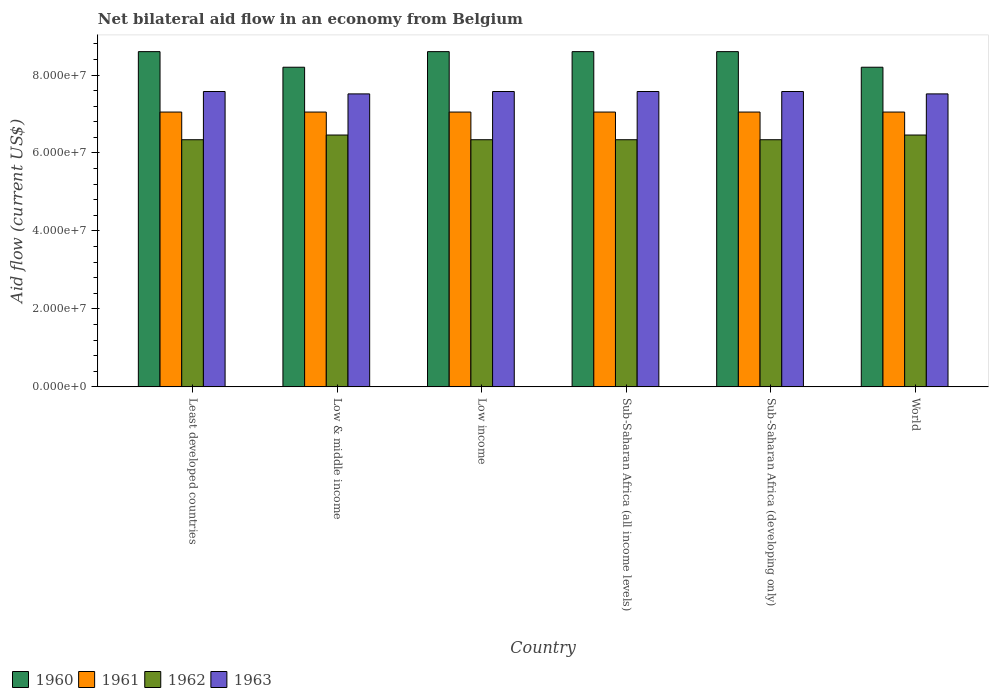How many groups of bars are there?
Your answer should be very brief. 6. Are the number of bars per tick equal to the number of legend labels?
Offer a very short reply. Yes. Are the number of bars on each tick of the X-axis equal?
Give a very brief answer. Yes. How many bars are there on the 6th tick from the left?
Keep it short and to the point. 4. In how many cases, is the number of bars for a given country not equal to the number of legend labels?
Ensure brevity in your answer.  0. What is the net bilateral aid flow in 1960 in Low income?
Your answer should be very brief. 8.60e+07. Across all countries, what is the maximum net bilateral aid flow in 1963?
Offer a terse response. 7.58e+07. Across all countries, what is the minimum net bilateral aid flow in 1962?
Provide a short and direct response. 6.34e+07. In which country was the net bilateral aid flow in 1963 maximum?
Your answer should be compact. Least developed countries. In which country was the net bilateral aid flow in 1962 minimum?
Your answer should be very brief. Least developed countries. What is the total net bilateral aid flow in 1962 in the graph?
Provide a short and direct response. 3.83e+08. What is the difference between the net bilateral aid flow in 1961 in Least developed countries and the net bilateral aid flow in 1960 in World?
Your answer should be compact. -1.15e+07. What is the average net bilateral aid flow in 1960 per country?
Give a very brief answer. 8.47e+07. What is the difference between the net bilateral aid flow of/in 1963 and net bilateral aid flow of/in 1960 in Low & middle income?
Provide a succinct answer. -6.84e+06. In how many countries, is the net bilateral aid flow in 1963 greater than 28000000 US$?
Your response must be concise. 6. What is the ratio of the net bilateral aid flow in 1962 in Low & middle income to that in Sub-Saharan Africa (all income levels)?
Provide a succinct answer. 1.02. Is the net bilateral aid flow in 1963 in Least developed countries less than that in World?
Make the answer very short. No. What is the difference between the highest and the second highest net bilateral aid flow in 1962?
Offer a very short reply. 1.21e+06. Is the sum of the net bilateral aid flow in 1962 in Sub-Saharan Africa (developing only) and World greater than the maximum net bilateral aid flow in 1963 across all countries?
Your response must be concise. Yes. Is it the case that in every country, the sum of the net bilateral aid flow in 1961 and net bilateral aid flow in 1960 is greater than the sum of net bilateral aid flow in 1963 and net bilateral aid flow in 1962?
Keep it short and to the point. No. What does the 1st bar from the left in Least developed countries represents?
Offer a very short reply. 1960. How many bars are there?
Your answer should be compact. 24. How many countries are there in the graph?
Keep it short and to the point. 6. What is the difference between two consecutive major ticks on the Y-axis?
Provide a short and direct response. 2.00e+07. Does the graph contain any zero values?
Give a very brief answer. No. Does the graph contain grids?
Provide a succinct answer. No. Where does the legend appear in the graph?
Provide a succinct answer. Bottom left. How many legend labels are there?
Your response must be concise. 4. How are the legend labels stacked?
Keep it short and to the point. Horizontal. What is the title of the graph?
Give a very brief answer. Net bilateral aid flow in an economy from Belgium. Does "2002" appear as one of the legend labels in the graph?
Ensure brevity in your answer.  No. What is the label or title of the Y-axis?
Offer a very short reply. Aid flow (current US$). What is the Aid flow (current US$) in 1960 in Least developed countries?
Your response must be concise. 8.60e+07. What is the Aid flow (current US$) in 1961 in Least developed countries?
Offer a terse response. 7.05e+07. What is the Aid flow (current US$) of 1962 in Least developed countries?
Your answer should be very brief. 6.34e+07. What is the Aid flow (current US$) in 1963 in Least developed countries?
Your answer should be very brief. 7.58e+07. What is the Aid flow (current US$) of 1960 in Low & middle income?
Provide a succinct answer. 8.20e+07. What is the Aid flow (current US$) of 1961 in Low & middle income?
Keep it short and to the point. 7.05e+07. What is the Aid flow (current US$) of 1962 in Low & middle income?
Your answer should be compact. 6.46e+07. What is the Aid flow (current US$) of 1963 in Low & middle income?
Provide a succinct answer. 7.52e+07. What is the Aid flow (current US$) of 1960 in Low income?
Provide a succinct answer. 8.60e+07. What is the Aid flow (current US$) in 1961 in Low income?
Your response must be concise. 7.05e+07. What is the Aid flow (current US$) of 1962 in Low income?
Give a very brief answer. 6.34e+07. What is the Aid flow (current US$) of 1963 in Low income?
Give a very brief answer. 7.58e+07. What is the Aid flow (current US$) of 1960 in Sub-Saharan Africa (all income levels)?
Offer a terse response. 8.60e+07. What is the Aid flow (current US$) in 1961 in Sub-Saharan Africa (all income levels)?
Keep it short and to the point. 7.05e+07. What is the Aid flow (current US$) of 1962 in Sub-Saharan Africa (all income levels)?
Give a very brief answer. 6.34e+07. What is the Aid flow (current US$) in 1963 in Sub-Saharan Africa (all income levels)?
Give a very brief answer. 7.58e+07. What is the Aid flow (current US$) of 1960 in Sub-Saharan Africa (developing only)?
Give a very brief answer. 8.60e+07. What is the Aid flow (current US$) of 1961 in Sub-Saharan Africa (developing only)?
Provide a succinct answer. 7.05e+07. What is the Aid flow (current US$) of 1962 in Sub-Saharan Africa (developing only)?
Provide a short and direct response. 6.34e+07. What is the Aid flow (current US$) of 1963 in Sub-Saharan Africa (developing only)?
Your response must be concise. 7.58e+07. What is the Aid flow (current US$) in 1960 in World?
Your answer should be compact. 8.20e+07. What is the Aid flow (current US$) of 1961 in World?
Your response must be concise. 7.05e+07. What is the Aid flow (current US$) in 1962 in World?
Make the answer very short. 6.46e+07. What is the Aid flow (current US$) in 1963 in World?
Your response must be concise. 7.52e+07. Across all countries, what is the maximum Aid flow (current US$) of 1960?
Your response must be concise. 8.60e+07. Across all countries, what is the maximum Aid flow (current US$) in 1961?
Make the answer very short. 7.05e+07. Across all countries, what is the maximum Aid flow (current US$) in 1962?
Offer a very short reply. 6.46e+07. Across all countries, what is the maximum Aid flow (current US$) of 1963?
Provide a succinct answer. 7.58e+07. Across all countries, what is the minimum Aid flow (current US$) of 1960?
Offer a terse response. 8.20e+07. Across all countries, what is the minimum Aid flow (current US$) in 1961?
Give a very brief answer. 7.05e+07. Across all countries, what is the minimum Aid flow (current US$) of 1962?
Offer a terse response. 6.34e+07. Across all countries, what is the minimum Aid flow (current US$) in 1963?
Offer a very short reply. 7.52e+07. What is the total Aid flow (current US$) of 1960 in the graph?
Offer a very short reply. 5.08e+08. What is the total Aid flow (current US$) of 1961 in the graph?
Make the answer very short. 4.23e+08. What is the total Aid flow (current US$) of 1962 in the graph?
Your answer should be very brief. 3.83e+08. What is the total Aid flow (current US$) in 1963 in the graph?
Ensure brevity in your answer.  4.53e+08. What is the difference between the Aid flow (current US$) of 1962 in Least developed countries and that in Low & middle income?
Ensure brevity in your answer.  -1.21e+06. What is the difference between the Aid flow (current US$) in 1961 in Least developed countries and that in Low income?
Provide a succinct answer. 0. What is the difference between the Aid flow (current US$) of 1963 in Least developed countries and that in Low income?
Your answer should be very brief. 0. What is the difference between the Aid flow (current US$) in 1962 in Least developed countries and that in Sub-Saharan Africa (all income levels)?
Ensure brevity in your answer.  0. What is the difference between the Aid flow (current US$) of 1960 in Least developed countries and that in Sub-Saharan Africa (developing only)?
Provide a short and direct response. 0. What is the difference between the Aid flow (current US$) in 1962 in Least developed countries and that in World?
Offer a terse response. -1.21e+06. What is the difference between the Aid flow (current US$) in 1960 in Low & middle income and that in Low income?
Your response must be concise. -4.00e+06. What is the difference between the Aid flow (current US$) in 1961 in Low & middle income and that in Low income?
Offer a very short reply. 0. What is the difference between the Aid flow (current US$) of 1962 in Low & middle income and that in Low income?
Your answer should be compact. 1.21e+06. What is the difference between the Aid flow (current US$) of 1963 in Low & middle income and that in Low income?
Ensure brevity in your answer.  -6.10e+05. What is the difference between the Aid flow (current US$) in 1960 in Low & middle income and that in Sub-Saharan Africa (all income levels)?
Give a very brief answer. -4.00e+06. What is the difference between the Aid flow (current US$) in 1961 in Low & middle income and that in Sub-Saharan Africa (all income levels)?
Ensure brevity in your answer.  0. What is the difference between the Aid flow (current US$) in 1962 in Low & middle income and that in Sub-Saharan Africa (all income levels)?
Offer a terse response. 1.21e+06. What is the difference between the Aid flow (current US$) of 1963 in Low & middle income and that in Sub-Saharan Africa (all income levels)?
Offer a terse response. -6.10e+05. What is the difference between the Aid flow (current US$) in 1962 in Low & middle income and that in Sub-Saharan Africa (developing only)?
Keep it short and to the point. 1.21e+06. What is the difference between the Aid flow (current US$) of 1963 in Low & middle income and that in Sub-Saharan Africa (developing only)?
Ensure brevity in your answer.  -6.10e+05. What is the difference between the Aid flow (current US$) in 1962 in Low & middle income and that in World?
Offer a very short reply. 0. What is the difference between the Aid flow (current US$) of 1963 in Low & middle income and that in World?
Your answer should be very brief. 0. What is the difference between the Aid flow (current US$) of 1960 in Low income and that in Sub-Saharan Africa (all income levels)?
Your answer should be very brief. 0. What is the difference between the Aid flow (current US$) of 1961 in Low income and that in Sub-Saharan Africa (all income levels)?
Keep it short and to the point. 0. What is the difference between the Aid flow (current US$) of 1963 in Low income and that in Sub-Saharan Africa (all income levels)?
Keep it short and to the point. 0. What is the difference between the Aid flow (current US$) in 1960 in Low income and that in Sub-Saharan Africa (developing only)?
Offer a very short reply. 0. What is the difference between the Aid flow (current US$) in 1961 in Low income and that in World?
Your response must be concise. 0. What is the difference between the Aid flow (current US$) of 1962 in Low income and that in World?
Provide a short and direct response. -1.21e+06. What is the difference between the Aid flow (current US$) of 1963 in Low income and that in World?
Keep it short and to the point. 6.10e+05. What is the difference between the Aid flow (current US$) in 1962 in Sub-Saharan Africa (all income levels) and that in Sub-Saharan Africa (developing only)?
Ensure brevity in your answer.  0. What is the difference between the Aid flow (current US$) of 1963 in Sub-Saharan Africa (all income levels) and that in Sub-Saharan Africa (developing only)?
Give a very brief answer. 0. What is the difference between the Aid flow (current US$) in 1962 in Sub-Saharan Africa (all income levels) and that in World?
Provide a succinct answer. -1.21e+06. What is the difference between the Aid flow (current US$) of 1963 in Sub-Saharan Africa (all income levels) and that in World?
Keep it short and to the point. 6.10e+05. What is the difference between the Aid flow (current US$) of 1961 in Sub-Saharan Africa (developing only) and that in World?
Provide a short and direct response. 0. What is the difference between the Aid flow (current US$) of 1962 in Sub-Saharan Africa (developing only) and that in World?
Offer a very short reply. -1.21e+06. What is the difference between the Aid flow (current US$) in 1963 in Sub-Saharan Africa (developing only) and that in World?
Provide a succinct answer. 6.10e+05. What is the difference between the Aid flow (current US$) in 1960 in Least developed countries and the Aid flow (current US$) in 1961 in Low & middle income?
Keep it short and to the point. 1.55e+07. What is the difference between the Aid flow (current US$) in 1960 in Least developed countries and the Aid flow (current US$) in 1962 in Low & middle income?
Your response must be concise. 2.14e+07. What is the difference between the Aid flow (current US$) of 1960 in Least developed countries and the Aid flow (current US$) of 1963 in Low & middle income?
Your answer should be very brief. 1.08e+07. What is the difference between the Aid flow (current US$) in 1961 in Least developed countries and the Aid flow (current US$) in 1962 in Low & middle income?
Your response must be concise. 5.89e+06. What is the difference between the Aid flow (current US$) of 1961 in Least developed countries and the Aid flow (current US$) of 1963 in Low & middle income?
Your answer should be very brief. -4.66e+06. What is the difference between the Aid flow (current US$) of 1962 in Least developed countries and the Aid flow (current US$) of 1963 in Low & middle income?
Make the answer very short. -1.18e+07. What is the difference between the Aid flow (current US$) of 1960 in Least developed countries and the Aid flow (current US$) of 1961 in Low income?
Your response must be concise. 1.55e+07. What is the difference between the Aid flow (current US$) in 1960 in Least developed countries and the Aid flow (current US$) in 1962 in Low income?
Your answer should be very brief. 2.26e+07. What is the difference between the Aid flow (current US$) in 1960 in Least developed countries and the Aid flow (current US$) in 1963 in Low income?
Offer a terse response. 1.02e+07. What is the difference between the Aid flow (current US$) in 1961 in Least developed countries and the Aid flow (current US$) in 1962 in Low income?
Your response must be concise. 7.10e+06. What is the difference between the Aid flow (current US$) in 1961 in Least developed countries and the Aid flow (current US$) in 1963 in Low income?
Ensure brevity in your answer.  -5.27e+06. What is the difference between the Aid flow (current US$) in 1962 in Least developed countries and the Aid flow (current US$) in 1963 in Low income?
Your answer should be compact. -1.24e+07. What is the difference between the Aid flow (current US$) of 1960 in Least developed countries and the Aid flow (current US$) of 1961 in Sub-Saharan Africa (all income levels)?
Provide a succinct answer. 1.55e+07. What is the difference between the Aid flow (current US$) in 1960 in Least developed countries and the Aid flow (current US$) in 1962 in Sub-Saharan Africa (all income levels)?
Provide a short and direct response. 2.26e+07. What is the difference between the Aid flow (current US$) of 1960 in Least developed countries and the Aid flow (current US$) of 1963 in Sub-Saharan Africa (all income levels)?
Your response must be concise. 1.02e+07. What is the difference between the Aid flow (current US$) of 1961 in Least developed countries and the Aid flow (current US$) of 1962 in Sub-Saharan Africa (all income levels)?
Keep it short and to the point. 7.10e+06. What is the difference between the Aid flow (current US$) in 1961 in Least developed countries and the Aid flow (current US$) in 1963 in Sub-Saharan Africa (all income levels)?
Provide a short and direct response. -5.27e+06. What is the difference between the Aid flow (current US$) in 1962 in Least developed countries and the Aid flow (current US$) in 1963 in Sub-Saharan Africa (all income levels)?
Your answer should be very brief. -1.24e+07. What is the difference between the Aid flow (current US$) of 1960 in Least developed countries and the Aid flow (current US$) of 1961 in Sub-Saharan Africa (developing only)?
Ensure brevity in your answer.  1.55e+07. What is the difference between the Aid flow (current US$) in 1960 in Least developed countries and the Aid flow (current US$) in 1962 in Sub-Saharan Africa (developing only)?
Give a very brief answer. 2.26e+07. What is the difference between the Aid flow (current US$) in 1960 in Least developed countries and the Aid flow (current US$) in 1963 in Sub-Saharan Africa (developing only)?
Give a very brief answer. 1.02e+07. What is the difference between the Aid flow (current US$) in 1961 in Least developed countries and the Aid flow (current US$) in 1962 in Sub-Saharan Africa (developing only)?
Your answer should be compact. 7.10e+06. What is the difference between the Aid flow (current US$) in 1961 in Least developed countries and the Aid flow (current US$) in 1963 in Sub-Saharan Africa (developing only)?
Offer a terse response. -5.27e+06. What is the difference between the Aid flow (current US$) of 1962 in Least developed countries and the Aid flow (current US$) of 1963 in Sub-Saharan Africa (developing only)?
Give a very brief answer. -1.24e+07. What is the difference between the Aid flow (current US$) in 1960 in Least developed countries and the Aid flow (current US$) in 1961 in World?
Your response must be concise. 1.55e+07. What is the difference between the Aid flow (current US$) in 1960 in Least developed countries and the Aid flow (current US$) in 1962 in World?
Keep it short and to the point. 2.14e+07. What is the difference between the Aid flow (current US$) in 1960 in Least developed countries and the Aid flow (current US$) in 1963 in World?
Make the answer very short. 1.08e+07. What is the difference between the Aid flow (current US$) in 1961 in Least developed countries and the Aid flow (current US$) in 1962 in World?
Make the answer very short. 5.89e+06. What is the difference between the Aid flow (current US$) of 1961 in Least developed countries and the Aid flow (current US$) of 1963 in World?
Your response must be concise. -4.66e+06. What is the difference between the Aid flow (current US$) of 1962 in Least developed countries and the Aid flow (current US$) of 1963 in World?
Offer a very short reply. -1.18e+07. What is the difference between the Aid flow (current US$) in 1960 in Low & middle income and the Aid flow (current US$) in 1961 in Low income?
Provide a short and direct response. 1.15e+07. What is the difference between the Aid flow (current US$) of 1960 in Low & middle income and the Aid flow (current US$) of 1962 in Low income?
Provide a succinct answer. 1.86e+07. What is the difference between the Aid flow (current US$) in 1960 in Low & middle income and the Aid flow (current US$) in 1963 in Low income?
Your response must be concise. 6.23e+06. What is the difference between the Aid flow (current US$) of 1961 in Low & middle income and the Aid flow (current US$) of 1962 in Low income?
Your answer should be compact. 7.10e+06. What is the difference between the Aid flow (current US$) of 1961 in Low & middle income and the Aid flow (current US$) of 1963 in Low income?
Your answer should be compact. -5.27e+06. What is the difference between the Aid flow (current US$) in 1962 in Low & middle income and the Aid flow (current US$) in 1963 in Low income?
Provide a short and direct response. -1.12e+07. What is the difference between the Aid flow (current US$) in 1960 in Low & middle income and the Aid flow (current US$) in 1961 in Sub-Saharan Africa (all income levels)?
Keep it short and to the point. 1.15e+07. What is the difference between the Aid flow (current US$) of 1960 in Low & middle income and the Aid flow (current US$) of 1962 in Sub-Saharan Africa (all income levels)?
Your answer should be compact. 1.86e+07. What is the difference between the Aid flow (current US$) of 1960 in Low & middle income and the Aid flow (current US$) of 1963 in Sub-Saharan Africa (all income levels)?
Ensure brevity in your answer.  6.23e+06. What is the difference between the Aid flow (current US$) of 1961 in Low & middle income and the Aid flow (current US$) of 1962 in Sub-Saharan Africa (all income levels)?
Make the answer very short. 7.10e+06. What is the difference between the Aid flow (current US$) in 1961 in Low & middle income and the Aid flow (current US$) in 1963 in Sub-Saharan Africa (all income levels)?
Offer a very short reply. -5.27e+06. What is the difference between the Aid flow (current US$) of 1962 in Low & middle income and the Aid flow (current US$) of 1963 in Sub-Saharan Africa (all income levels)?
Provide a short and direct response. -1.12e+07. What is the difference between the Aid flow (current US$) of 1960 in Low & middle income and the Aid flow (current US$) of 1961 in Sub-Saharan Africa (developing only)?
Your answer should be very brief. 1.15e+07. What is the difference between the Aid flow (current US$) of 1960 in Low & middle income and the Aid flow (current US$) of 1962 in Sub-Saharan Africa (developing only)?
Provide a succinct answer. 1.86e+07. What is the difference between the Aid flow (current US$) in 1960 in Low & middle income and the Aid flow (current US$) in 1963 in Sub-Saharan Africa (developing only)?
Provide a succinct answer. 6.23e+06. What is the difference between the Aid flow (current US$) of 1961 in Low & middle income and the Aid flow (current US$) of 1962 in Sub-Saharan Africa (developing only)?
Ensure brevity in your answer.  7.10e+06. What is the difference between the Aid flow (current US$) of 1961 in Low & middle income and the Aid flow (current US$) of 1963 in Sub-Saharan Africa (developing only)?
Your answer should be compact. -5.27e+06. What is the difference between the Aid flow (current US$) in 1962 in Low & middle income and the Aid flow (current US$) in 1963 in Sub-Saharan Africa (developing only)?
Offer a very short reply. -1.12e+07. What is the difference between the Aid flow (current US$) of 1960 in Low & middle income and the Aid flow (current US$) of 1961 in World?
Your response must be concise. 1.15e+07. What is the difference between the Aid flow (current US$) in 1960 in Low & middle income and the Aid flow (current US$) in 1962 in World?
Keep it short and to the point. 1.74e+07. What is the difference between the Aid flow (current US$) in 1960 in Low & middle income and the Aid flow (current US$) in 1963 in World?
Offer a terse response. 6.84e+06. What is the difference between the Aid flow (current US$) in 1961 in Low & middle income and the Aid flow (current US$) in 1962 in World?
Ensure brevity in your answer.  5.89e+06. What is the difference between the Aid flow (current US$) of 1961 in Low & middle income and the Aid flow (current US$) of 1963 in World?
Keep it short and to the point. -4.66e+06. What is the difference between the Aid flow (current US$) in 1962 in Low & middle income and the Aid flow (current US$) in 1963 in World?
Make the answer very short. -1.06e+07. What is the difference between the Aid flow (current US$) of 1960 in Low income and the Aid flow (current US$) of 1961 in Sub-Saharan Africa (all income levels)?
Your answer should be compact. 1.55e+07. What is the difference between the Aid flow (current US$) of 1960 in Low income and the Aid flow (current US$) of 1962 in Sub-Saharan Africa (all income levels)?
Make the answer very short. 2.26e+07. What is the difference between the Aid flow (current US$) of 1960 in Low income and the Aid flow (current US$) of 1963 in Sub-Saharan Africa (all income levels)?
Ensure brevity in your answer.  1.02e+07. What is the difference between the Aid flow (current US$) in 1961 in Low income and the Aid flow (current US$) in 1962 in Sub-Saharan Africa (all income levels)?
Provide a succinct answer. 7.10e+06. What is the difference between the Aid flow (current US$) in 1961 in Low income and the Aid flow (current US$) in 1963 in Sub-Saharan Africa (all income levels)?
Ensure brevity in your answer.  -5.27e+06. What is the difference between the Aid flow (current US$) in 1962 in Low income and the Aid flow (current US$) in 1963 in Sub-Saharan Africa (all income levels)?
Your answer should be very brief. -1.24e+07. What is the difference between the Aid flow (current US$) of 1960 in Low income and the Aid flow (current US$) of 1961 in Sub-Saharan Africa (developing only)?
Your response must be concise. 1.55e+07. What is the difference between the Aid flow (current US$) of 1960 in Low income and the Aid flow (current US$) of 1962 in Sub-Saharan Africa (developing only)?
Provide a succinct answer. 2.26e+07. What is the difference between the Aid flow (current US$) in 1960 in Low income and the Aid flow (current US$) in 1963 in Sub-Saharan Africa (developing only)?
Offer a terse response. 1.02e+07. What is the difference between the Aid flow (current US$) in 1961 in Low income and the Aid flow (current US$) in 1962 in Sub-Saharan Africa (developing only)?
Your answer should be compact. 7.10e+06. What is the difference between the Aid flow (current US$) of 1961 in Low income and the Aid flow (current US$) of 1963 in Sub-Saharan Africa (developing only)?
Offer a terse response. -5.27e+06. What is the difference between the Aid flow (current US$) in 1962 in Low income and the Aid flow (current US$) in 1963 in Sub-Saharan Africa (developing only)?
Your answer should be very brief. -1.24e+07. What is the difference between the Aid flow (current US$) in 1960 in Low income and the Aid flow (current US$) in 1961 in World?
Offer a very short reply. 1.55e+07. What is the difference between the Aid flow (current US$) in 1960 in Low income and the Aid flow (current US$) in 1962 in World?
Your response must be concise. 2.14e+07. What is the difference between the Aid flow (current US$) of 1960 in Low income and the Aid flow (current US$) of 1963 in World?
Make the answer very short. 1.08e+07. What is the difference between the Aid flow (current US$) in 1961 in Low income and the Aid flow (current US$) in 1962 in World?
Your answer should be compact. 5.89e+06. What is the difference between the Aid flow (current US$) of 1961 in Low income and the Aid flow (current US$) of 1963 in World?
Your response must be concise. -4.66e+06. What is the difference between the Aid flow (current US$) in 1962 in Low income and the Aid flow (current US$) in 1963 in World?
Your response must be concise. -1.18e+07. What is the difference between the Aid flow (current US$) in 1960 in Sub-Saharan Africa (all income levels) and the Aid flow (current US$) in 1961 in Sub-Saharan Africa (developing only)?
Your answer should be very brief. 1.55e+07. What is the difference between the Aid flow (current US$) of 1960 in Sub-Saharan Africa (all income levels) and the Aid flow (current US$) of 1962 in Sub-Saharan Africa (developing only)?
Give a very brief answer. 2.26e+07. What is the difference between the Aid flow (current US$) of 1960 in Sub-Saharan Africa (all income levels) and the Aid flow (current US$) of 1963 in Sub-Saharan Africa (developing only)?
Keep it short and to the point. 1.02e+07. What is the difference between the Aid flow (current US$) of 1961 in Sub-Saharan Africa (all income levels) and the Aid flow (current US$) of 1962 in Sub-Saharan Africa (developing only)?
Your response must be concise. 7.10e+06. What is the difference between the Aid flow (current US$) of 1961 in Sub-Saharan Africa (all income levels) and the Aid flow (current US$) of 1963 in Sub-Saharan Africa (developing only)?
Your answer should be very brief. -5.27e+06. What is the difference between the Aid flow (current US$) of 1962 in Sub-Saharan Africa (all income levels) and the Aid flow (current US$) of 1963 in Sub-Saharan Africa (developing only)?
Your answer should be very brief. -1.24e+07. What is the difference between the Aid flow (current US$) of 1960 in Sub-Saharan Africa (all income levels) and the Aid flow (current US$) of 1961 in World?
Make the answer very short. 1.55e+07. What is the difference between the Aid flow (current US$) of 1960 in Sub-Saharan Africa (all income levels) and the Aid flow (current US$) of 1962 in World?
Offer a terse response. 2.14e+07. What is the difference between the Aid flow (current US$) of 1960 in Sub-Saharan Africa (all income levels) and the Aid flow (current US$) of 1963 in World?
Make the answer very short. 1.08e+07. What is the difference between the Aid flow (current US$) in 1961 in Sub-Saharan Africa (all income levels) and the Aid flow (current US$) in 1962 in World?
Offer a terse response. 5.89e+06. What is the difference between the Aid flow (current US$) of 1961 in Sub-Saharan Africa (all income levels) and the Aid flow (current US$) of 1963 in World?
Offer a very short reply. -4.66e+06. What is the difference between the Aid flow (current US$) of 1962 in Sub-Saharan Africa (all income levels) and the Aid flow (current US$) of 1963 in World?
Your answer should be compact. -1.18e+07. What is the difference between the Aid flow (current US$) of 1960 in Sub-Saharan Africa (developing only) and the Aid flow (current US$) of 1961 in World?
Give a very brief answer. 1.55e+07. What is the difference between the Aid flow (current US$) of 1960 in Sub-Saharan Africa (developing only) and the Aid flow (current US$) of 1962 in World?
Keep it short and to the point. 2.14e+07. What is the difference between the Aid flow (current US$) in 1960 in Sub-Saharan Africa (developing only) and the Aid flow (current US$) in 1963 in World?
Your answer should be compact. 1.08e+07. What is the difference between the Aid flow (current US$) of 1961 in Sub-Saharan Africa (developing only) and the Aid flow (current US$) of 1962 in World?
Provide a succinct answer. 5.89e+06. What is the difference between the Aid flow (current US$) in 1961 in Sub-Saharan Africa (developing only) and the Aid flow (current US$) in 1963 in World?
Provide a succinct answer. -4.66e+06. What is the difference between the Aid flow (current US$) of 1962 in Sub-Saharan Africa (developing only) and the Aid flow (current US$) of 1963 in World?
Keep it short and to the point. -1.18e+07. What is the average Aid flow (current US$) in 1960 per country?
Ensure brevity in your answer.  8.47e+07. What is the average Aid flow (current US$) in 1961 per country?
Provide a short and direct response. 7.05e+07. What is the average Aid flow (current US$) in 1962 per country?
Keep it short and to the point. 6.38e+07. What is the average Aid flow (current US$) in 1963 per country?
Ensure brevity in your answer.  7.56e+07. What is the difference between the Aid flow (current US$) in 1960 and Aid flow (current US$) in 1961 in Least developed countries?
Give a very brief answer. 1.55e+07. What is the difference between the Aid flow (current US$) of 1960 and Aid flow (current US$) of 1962 in Least developed countries?
Your answer should be very brief. 2.26e+07. What is the difference between the Aid flow (current US$) of 1960 and Aid flow (current US$) of 1963 in Least developed countries?
Your answer should be compact. 1.02e+07. What is the difference between the Aid flow (current US$) of 1961 and Aid flow (current US$) of 1962 in Least developed countries?
Provide a short and direct response. 7.10e+06. What is the difference between the Aid flow (current US$) in 1961 and Aid flow (current US$) in 1963 in Least developed countries?
Give a very brief answer. -5.27e+06. What is the difference between the Aid flow (current US$) of 1962 and Aid flow (current US$) of 1963 in Least developed countries?
Keep it short and to the point. -1.24e+07. What is the difference between the Aid flow (current US$) of 1960 and Aid flow (current US$) of 1961 in Low & middle income?
Your answer should be very brief. 1.15e+07. What is the difference between the Aid flow (current US$) in 1960 and Aid flow (current US$) in 1962 in Low & middle income?
Make the answer very short. 1.74e+07. What is the difference between the Aid flow (current US$) in 1960 and Aid flow (current US$) in 1963 in Low & middle income?
Your answer should be very brief. 6.84e+06. What is the difference between the Aid flow (current US$) in 1961 and Aid flow (current US$) in 1962 in Low & middle income?
Your answer should be very brief. 5.89e+06. What is the difference between the Aid flow (current US$) of 1961 and Aid flow (current US$) of 1963 in Low & middle income?
Provide a succinct answer. -4.66e+06. What is the difference between the Aid flow (current US$) of 1962 and Aid flow (current US$) of 1963 in Low & middle income?
Your answer should be very brief. -1.06e+07. What is the difference between the Aid flow (current US$) in 1960 and Aid flow (current US$) in 1961 in Low income?
Provide a short and direct response. 1.55e+07. What is the difference between the Aid flow (current US$) in 1960 and Aid flow (current US$) in 1962 in Low income?
Offer a terse response. 2.26e+07. What is the difference between the Aid flow (current US$) of 1960 and Aid flow (current US$) of 1963 in Low income?
Your response must be concise. 1.02e+07. What is the difference between the Aid flow (current US$) of 1961 and Aid flow (current US$) of 1962 in Low income?
Your answer should be very brief. 7.10e+06. What is the difference between the Aid flow (current US$) of 1961 and Aid flow (current US$) of 1963 in Low income?
Keep it short and to the point. -5.27e+06. What is the difference between the Aid flow (current US$) in 1962 and Aid flow (current US$) in 1963 in Low income?
Offer a terse response. -1.24e+07. What is the difference between the Aid flow (current US$) of 1960 and Aid flow (current US$) of 1961 in Sub-Saharan Africa (all income levels)?
Ensure brevity in your answer.  1.55e+07. What is the difference between the Aid flow (current US$) in 1960 and Aid flow (current US$) in 1962 in Sub-Saharan Africa (all income levels)?
Offer a terse response. 2.26e+07. What is the difference between the Aid flow (current US$) in 1960 and Aid flow (current US$) in 1963 in Sub-Saharan Africa (all income levels)?
Keep it short and to the point. 1.02e+07. What is the difference between the Aid flow (current US$) of 1961 and Aid flow (current US$) of 1962 in Sub-Saharan Africa (all income levels)?
Your response must be concise. 7.10e+06. What is the difference between the Aid flow (current US$) in 1961 and Aid flow (current US$) in 1963 in Sub-Saharan Africa (all income levels)?
Offer a very short reply. -5.27e+06. What is the difference between the Aid flow (current US$) in 1962 and Aid flow (current US$) in 1963 in Sub-Saharan Africa (all income levels)?
Offer a terse response. -1.24e+07. What is the difference between the Aid flow (current US$) of 1960 and Aid flow (current US$) of 1961 in Sub-Saharan Africa (developing only)?
Keep it short and to the point. 1.55e+07. What is the difference between the Aid flow (current US$) in 1960 and Aid flow (current US$) in 1962 in Sub-Saharan Africa (developing only)?
Ensure brevity in your answer.  2.26e+07. What is the difference between the Aid flow (current US$) of 1960 and Aid flow (current US$) of 1963 in Sub-Saharan Africa (developing only)?
Offer a very short reply. 1.02e+07. What is the difference between the Aid flow (current US$) of 1961 and Aid flow (current US$) of 1962 in Sub-Saharan Africa (developing only)?
Your response must be concise. 7.10e+06. What is the difference between the Aid flow (current US$) in 1961 and Aid flow (current US$) in 1963 in Sub-Saharan Africa (developing only)?
Make the answer very short. -5.27e+06. What is the difference between the Aid flow (current US$) in 1962 and Aid flow (current US$) in 1963 in Sub-Saharan Africa (developing only)?
Provide a succinct answer. -1.24e+07. What is the difference between the Aid flow (current US$) of 1960 and Aid flow (current US$) of 1961 in World?
Your answer should be compact. 1.15e+07. What is the difference between the Aid flow (current US$) of 1960 and Aid flow (current US$) of 1962 in World?
Offer a very short reply. 1.74e+07. What is the difference between the Aid flow (current US$) of 1960 and Aid flow (current US$) of 1963 in World?
Provide a short and direct response. 6.84e+06. What is the difference between the Aid flow (current US$) in 1961 and Aid flow (current US$) in 1962 in World?
Provide a succinct answer. 5.89e+06. What is the difference between the Aid flow (current US$) in 1961 and Aid flow (current US$) in 1963 in World?
Offer a very short reply. -4.66e+06. What is the difference between the Aid flow (current US$) in 1962 and Aid flow (current US$) in 1963 in World?
Your answer should be very brief. -1.06e+07. What is the ratio of the Aid flow (current US$) in 1960 in Least developed countries to that in Low & middle income?
Keep it short and to the point. 1.05. What is the ratio of the Aid flow (current US$) in 1961 in Least developed countries to that in Low & middle income?
Keep it short and to the point. 1. What is the ratio of the Aid flow (current US$) of 1962 in Least developed countries to that in Low & middle income?
Your answer should be very brief. 0.98. What is the ratio of the Aid flow (current US$) in 1963 in Least developed countries to that in Low & middle income?
Your response must be concise. 1.01. What is the ratio of the Aid flow (current US$) of 1961 in Least developed countries to that in Low income?
Offer a very short reply. 1. What is the ratio of the Aid flow (current US$) of 1963 in Least developed countries to that in Low income?
Offer a terse response. 1. What is the ratio of the Aid flow (current US$) in 1960 in Least developed countries to that in Sub-Saharan Africa (all income levels)?
Ensure brevity in your answer.  1. What is the ratio of the Aid flow (current US$) in 1962 in Least developed countries to that in Sub-Saharan Africa (all income levels)?
Offer a very short reply. 1. What is the ratio of the Aid flow (current US$) in 1960 in Least developed countries to that in Sub-Saharan Africa (developing only)?
Offer a terse response. 1. What is the ratio of the Aid flow (current US$) in 1960 in Least developed countries to that in World?
Keep it short and to the point. 1.05. What is the ratio of the Aid flow (current US$) in 1961 in Least developed countries to that in World?
Give a very brief answer. 1. What is the ratio of the Aid flow (current US$) of 1962 in Least developed countries to that in World?
Provide a succinct answer. 0.98. What is the ratio of the Aid flow (current US$) of 1960 in Low & middle income to that in Low income?
Offer a very short reply. 0.95. What is the ratio of the Aid flow (current US$) in 1962 in Low & middle income to that in Low income?
Give a very brief answer. 1.02. What is the ratio of the Aid flow (current US$) of 1960 in Low & middle income to that in Sub-Saharan Africa (all income levels)?
Give a very brief answer. 0.95. What is the ratio of the Aid flow (current US$) of 1961 in Low & middle income to that in Sub-Saharan Africa (all income levels)?
Ensure brevity in your answer.  1. What is the ratio of the Aid flow (current US$) of 1962 in Low & middle income to that in Sub-Saharan Africa (all income levels)?
Give a very brief answer. 1.02. What is the ratio of the Aid flow (current US$) of 1960 in Low & middle income to that in Sub-Saharan Africa (developing only)?
Provide a succinct answer. 0.95. What is the ratio of the Aid flow (current US$) in 1961 in Low & middle income to that in Sub-Saharan Africa (developing only)?
Ensure brevity in your answer.  1. What is the ratio of the Aid flow (current US$) of 1962 in Low & middle income to that in Sub-Saharan Africa (developing only)?
Make the answer very short. 1.02. What is the ratio of the Aid flow (current US$) of 1962 in Low & middle income to that in World?
Provide a succinct answer. 1. What is the ratio of the Aid flow (current US$) of 1963 in Low & middle income to that in World?
Your answer should be very brief. 1. What is the ratio of the Aid flow (current US$) of 1961 in Low income to that in Sub-Saharan Africa (all income levels)?
Your answer should be compact. 1. What is the ratio of the Aid flow (current US$) in 1962 in Low income to that in Sub-Saharan Africa (all income levels)?
Give a very brief answer. 1. What is the ratio of the Aid flow (current US$) of 1961 in Low income to that in Sub-Saharan Africa (developing only)?
Keep it short and to the point. 1. What is the ratio of the Aid flow (current US$) of 1960 in Low income to that in World?
Keep it short and to the point. 1.05. What is the ratio of the Aid flow (current US$) in 1962 in Low income to that in World?
Provide a short and direct response. 0.98. What is the ratio of the Aid flow (current US$) of 1960 in Sub-Saharan Africa (all income levels) to that in Sub-Saharan Africa (developing only)?
Your answer should be very brief. 1. What is the ratio of the Aid flow (current US$) in 1962 in Sub-Saharan Africa (all income levels) to that in Sub-Saharan Africa (developing only)?
Your answer should be compact. 1. What is the ratio of the Aid flow (current US$) in 1963 in Sub-Saharan Africa (all income levels) to that in Sub-Saharan Africa (developing only)?
Give a very brief answer. 1. What is the ratio of the Aid flow (current US$) of 1960 in Sub-Saharan Africa (all income levels) to that in World?
Your answer should be very brief. 1.05. What is the ratio of the Aid flow (current US$) in 1961 in Sub-Saharan Africa (all income levels) to that in World?
Provide a short and direct response. 1. What is the ratio of the Aid flow (current US$) of 1962 in Sub-Saharan Africa (all income levels) to that in World?
Ensure brevity in your answer.  0.98. What is the ratio of the Aid flow (current US$) in 1963 in Sub-Saharan Africa (all income levels) to that in World?
Make the answer very short. 1.01. What is the ratio of the Aid flow (current US$) in 1960 in Sub-Saharan Africa (developing only) to that in World?
Your response must be concise. 1.05. What is the ratio of the Aid flow (current US$) in 1961 in Sub-Saharan Africa (developing only) to that in World?
Provide a short and direct response. 1. What is the ratio of the Aid flow (current US$) in 1962 in Sub-Saharan Africa (developing only) to that in World?
Provide a short and direct response. 0.98. What is the ratio of the Aid flow (current US$) in 1963 in Sub-Saharan Africa (developing only) to that in World?
Keep it short and to the point. 1.01. What is the difference between the highest and the second highest Aid flow (current US$) of 1960?
Ensure brevity in your answer.  0. What is the difference between the highest and the second highest Aid flow (current US$) in 1962?
Offer a very short reply. 0. What is the difference between the highest and the second highest Aid flow (current US$) of 1963?
Offer a terse response. 0. What is the difference between the highest and the lowest Aid flow (current US$) of 1961?
Make the answer very short. 0. What is the difference between the highest and the lowest Aid flow (current US$) of 1962?
Provide a succinct answer. 1.21e+06. What is the difference between the highest and the lowest Aid flow (current US$) of 1963?
Keep it short and to the point. 6.10e+05. 